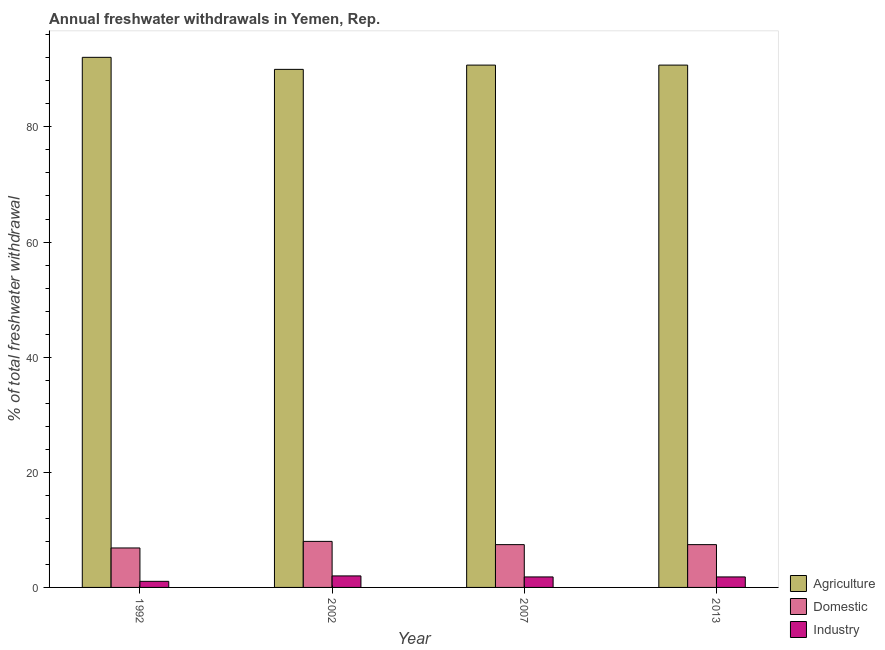How many groups of bars are there?
Ensure brevity in your answer.  4. How many bars are there on the 2nd tick from the left?
Offer a terse response. 3. How many bars are there on the 4th tick from the right?
Your answer should be very brief. 3. In how many cases, is the number of bars for a given year not equal to the number of legend labels?
Your answer should be compact. 0. What is the percentage of freshwater withdrawal for domestic purposes in 2007?
Provide a succinct answer. 7.43. Across all years, what is the maximum percentage of freshwater withdrawal for industry?
Offer a very short reply. 2. Across all years, what is the minimum percentage of freshwater withdrawal for domestic purposes?
Give a very brief answer. 6.86. In which year was the percentage of freshwater withdrawal for domestic purposes maximum?
Provide a succinct answer. 2002. What is the total percentage of freshwater withdrawal for agriculture in the graph?
Provide a succinct answer. 363.57. What is the difference between the percentage of freshwater withdrawal for domestic purposes in 2002 and that in 2007?
Your answer should be very brief. 0.57. What is the average percentage of freshwater withdrawal for industry per year?
Offer a very short reply. 1.68. In the year 2002, what is the difference between the percentage of freshwater withdrawal for domestic purposes and percentage of freshwater withdrawal for agriculture?
Make the answer very short. 0. What is the ratio of the percentage of freshwater withdrawal for agriculture in 2002 to that in 2007?
Offer a very short reply. 0.99. Is the percentage of freshwater withdrawal for agriculture in 2002 less than that in 2013?
Give a very brief answer. Yes. What is the difference between the highest and the second highest percentage of freshwater withdrawal for industry?
Keep it short and to the point. 0.18. What is the difference between the highest and the lowest percentage of freshwater withdrawal for industry?
Your answer should be very brief. 0.94. In how many years, is the percentage of freshwater withdrawal for industry greater than the average percentage of freshwater withdrawal for industry taken over all years?
Provide a short and direct response. 3. What does the 2nd bar from the left in 2002 represents?
Give a very brief answer. Domestic. What does the 2nd bar from the right in 2007 represents?
Your response must be concise. Domestic. What is the difference between two consecutive major ticks on the Y-axis?
Provide a short and direct response. 20. Does the graph contain grids?
Provide a succinct answer. No. Where does the legend appear in the graph?
Your answer should be compact. Bottom right. What is the title of the graph?
Your answer should be compact. Annual freshwater withdrawals in Yemen, Rep. What is the label or title of the Y-axis?
Your response must be concise. % of total freshwater withdrawal. What is the % of total freshwater withdrawal in Agriculture in 1992?
Provide a succinct answer. 92.09. What is the % of total freshwater withdrawal in Domestic in 1992?
Offer a very short reply. 6.86. What is the % of total freshwater withdrawal of Industry in 1992?
Provide a succinct answer. 1.06. What is the % of total freshwater withdrawal of Domestic in 2002?
Offer a very short reply. 8. What is the % of total freshwater withdrawal of Industry in 2002?
Your response must be concise. 2. What is the % of total freshwater withdrawal of Agriculture in 2007?
Your answer should be compact. 90.74. What is the % of total freshwater withdrawal of Domestic in 2007?
Provide a short and direct response. 7.43. What is the % of total freshwater withdrawal of Industry in 2007?
Your response must be concise. 1.82. What is the % of total freshwater withdrawal in Agriculture in 2013?
Keep it short and to the point. 90.74. What is the % of total freshwater withdrawal in Domestic in 2013?
Your response must be concise. 7.43. What is the % of total freshwater withdrawal in Industry in 2013?
Provide a short and direct response. 1.82. Across all years, what is the maximum % of total freshwater withdrawal of Agriculture?
Make the answer very short. 92.09. Across all years, what is the maximum % of total freshwater withdrawal of Domestic?
Make the answer very short. 8. Across all years, what is the minimum % of total freshwater withdrawal of Domestic?
Make the answer very short. 6.86. Across all years, what is the minimum % of total freshwater withdrawal in Industry?
Your answer should be very brief. 1.06. What is the total % of total freshwater withdrawal of Agriculture in the graph?
Keep it short and to the point. 363.57. What is the total % of total freshwater withdrawal of Domestic in the graph?
Offer a very short reply. 29.72. What is the total % of total freshwater withdrawal in Industry in the graph?
Keep it short and to the point. 6.7. What is the difference between the % of total freshwater withdrawal in Agriculture in 1992 and that in 2002?
Make the answer very short. 2.09. What is the difference between the % of total freshwater withdrawal of Domestic in 1992 and that in 2002?
Provide a succinct answer. -1.15. What is the difference between the % of total freshwater withdrawal in Industry in 1992 and that in 2002?
Provide a short and direct response. -0.94. What is the difference between the % of total freshwater withdrawal in Agriculture in 1992 and that in 2007?
Keep it short and to the point. 1.35. What is the difference between the % of total freshwater withdrawal in Domestic in 1992 and that in 2007?
Provide a succinct answer. -0.58. What is the difference between the % of total freshwater withdrawal of Industry in 1992 and that in 2007?
Offer a terse response. -0.77. What is the difference between the % of total freshwater withdrawal in Agriculture in 1992 and that in 2013?
Ensure brevity in your answer.  1.35. What is the difference between the % of total freshwater withdrawal in Domestic in 1992 and that in 2013?
Offer a terse response. -0.58. What is the difference between the % of total freshwater withdrawal in Industry in 1992 and that in 2013?
Make the answer very short. -0.77. What is the difference between the % of total freshwater withdrawal in Agriculture in 2002 and that in 2007?
Your answer should be very brief. -0.74. What is the difference between the % of total freshwater withdrawal in Domestic in 2002 and that in 2007?
Your response must be concise. 0.57. What is the difference between the % of total freshwater withdrawal in Industry in 2002 and that in 2007?
Offer a terse response. 0.18. What is the difference between the % of total freshwater withdrawal of Agriculture in 2002 and that in 2013?
Give a very brief answer. -0.74. What is the difference between the % of total freshwater withdrawal of Domestic in 2002 and that in 2013?
Provide a short and direct response. 0.57. What is the difference between the % of total freshwater withdrawal of Industry in 2002 and that in 2013?
Ensure brevity in your answer.  0.18. What is the difference between the % of total freshwater withdrawal in Domestic in 2007 and that in 2013?
Offer a very short reply. 0. What is the difference between the % of total freshwater withdrawal in Agriculture in 1992 and the % of total freshwater withdrawal in Domestic in 2002?
Offer a terse response. 84.09. What is the difference between the % of total freshwater withdrawal in Agriculture in 1992 and the % of total freshwater withdrawal in Industry in 2002?
Ensure brevity in your answer.  90.09. What is the difference between the % of total freshwater withdrawal in Domestic in 1992 and the % of total freshwater withdrawal in Industry in 2002?
Give a very brief answer. 4.86. What is the difference between the % of total freshwater withdrawal in Agriculture in 1992 and the % of total freshwater withdrawal in Domestic in 2007?
Your response must be concise. 84.66. What is the difference between the % of total freshwater withdrawal of Agriculture in 1992 and the % of total freshwater withdrawal of Industry in 2007?
Your response must be concise. 90.27. What is the difference between the % of total freshwater withdrawal of Domestic in 1992 and the % of total freshwater withdrawal of Industry in 2007?
Keep it short and to the point. 5.03. What is the difference between the % of total freshwater withdrawal in Agriculture in 1992 and the % of total freshwater withdrawal in Domestic in 2013?
Make the answer very short. 84.66. What is the difference between the % of total freshwater withdrawal in Agriculture in 1992 and the % of total freshwater withdrawal in Industry in 2013?
Keep it short and to the point. 90.27. What is the difference between the % of total freshwater withdrawal of Domestic in 1992 and the % of total freshwater withdrawal of Industry in 2013?
Offer a very short reply. 5.03. What is the difference between the % of total freshwater withdrawal in Agriculture in 2002 and the % of total freshwater withdrawal in Domestic in 2007?
Make the answer very short. 82.57. What is the difference between the % of total freshwater withdrawal of Agriculture in 2002 and the % of total freshwater withdrawal of Industry in 2007?
Your answer should be compact. 88.18. What is the difference between the % of total freshwater withdrawal in Domestic in 2002 and the % of total freshwater withdrawal in Industry in 2007?
Your answer should be compact. 6.18. What is the difference between the % of total freshwater withdrawal in Agriculture in 2002 and the % of total freshwater withdrawal in Domestic in 2013?
Your answer should be very brief. 82.57. What is the difference between the % of total freshwater withdrawal in Agriculture in 2002 and the % of total freshwater withdrawal in Industry in 2013?
Your response must be concise. 88.18. What is the difference between the % of total freshwater withdrawal of Domestic in 2002 and the % of total freshwater withdrawal of Industry in 2013?
Your response must be concise. 6.18. What is the difference between the % of total freshwater withdrawal of Agriculture in 2007 and the % of total freshwater withdrawal of Domestic in 2013?
Your answer should be compact. 83.31. What is the difference between the % of total freshwater withdrawal in Agriculture in 2007 and the % of total freshwater withdrawal in Industry in 2013?
Your answer should be very brief. 88.92. What is the difference between the % of total freshwater withdrawal of Domestic in 2007 and the % of total freshwater withdrawal of Industry in 2013?
Give a very brief answer. 5.61. What is the average % of total freshwater withdrawal of Agriculture per year?
Make the answer very short. 90.89. What is the average % of total freshwater withdrawal in Domestic per year?
Make the answer very short. 7.43. What is the average % of total freshwater withdrawal in Industry per year?
Provide a short and direct response. 1.68. In the year 1992, what is the difference between the % of total freshwater withdrawal of Agriculture and % of total freshwater withdrawal of Domestic?
Give a very brief answer. 85.23. In the year 1992, what is the difference between the % of total freshwater withdrawal of Agriculture and % of total freshwater withdrawal of Industry?
Your answer should be very brief. 91.03. In the year 1992, what is the difference between the % of total freshwater withdrawal of Domestic and % of total freshwater withdrawal of Industry?
Give a very brief answer. 5.8. In the year 2002, what is the difference between the % of total freshwater withdrawal in Domestic and % of total freshwater withdrawal in Industry?
Make the answer very short. 6. In the year 2007, what is the difference between the % of total freshwater withdrawal of Agriculture and % of total freshwater withdrawal of Domestic?
Ensure brevity in your answer.  83.31. In the year 2007, what is the difference between the % of total freshwater withdrawal in Agriculture and % of total freshwater withdrawal in Industry?
Your answer should be very brief. 88.92. In the year 2007, what is the difference between the % of total freshwater withdrawal of Domestic and % of total freshwater withdrawal of Industry?
Provide a succinct answer. 5.61. In the year 2013, what is the difference between the % of total freshwater withdrawal of Agriculture and % of total freshwater withdrawal of Domestic?
Your answer should be compact. 83.31. In the year 2013, what is the difference between the % of total freshwater withdrawal of Agriculture and % of total freshwater withdrawal of Industry?
Ensure brevity in your answer.  88.92. In the year 2013, what is the difference between the % of total freshwater withdrawal of Domestic and % of total freshwater withdrawal of Industry?
Your answer should be very brief. 5.61. What is the ratio of the % of total freshwater withdrawal in Agriculture in 1992 to that in 2002?
Offer a very short reply. 1.02. What is the ratio of the % of total freshwater withdrawal in Domestic in 1992 to that in 2002?
Your answer should be very brief. 0.86. What is the ratio of the % of total freshwater withdrawal of Industry in 1992 to that in 2002?
Your answer should be very brief. 0.53. What is the ratio of the % of total freshwater withdrawal of Agriculture in 1992 to that in 2007?
Provide a succinct answer. 1.01. What is the ratio of the % of total freshwater withdrawal of Domestic in 1992 to that in 2007?
Give a very brief answer. 0.92. What is the ratio of the % of total freshwater withdrawal in Industry in 1992 to that in 2007?
Ensure brevity in your answer.  0.58. What is the ratio of the % of total freshwater withdrawal in Agriculture in 1992 to that in 2013?
Your answer should be very brief. 1.01. What is the ratio of the % of total freshwater withdrawal in Domestic in 1992 to that in 2013?
Offer a terse response. 0.92. What is the ratio of the % of total freshwater withdrawal in Industry in 1992 to that in 2013?
Give a very brief answer. 0.58. What is the ratio of the % of total freshwater withdrawal of Domestic in 2002 to that in 2007?
Offer a very short reply. 1.08. What is the ratio of the % of total freshwater withdrawal in Industry in 2002 to that in 2007?
Your response must be concise. 1.1. What is the ratio of the % of total freshwater withdrawal of Domestic in 2002 to that in 2013?
Provide a short and direct response. 1.08. What is the ratio of the % of total freshwater withdrawal in Industry in 2002 to that in 2013?
Make the answer very short. 1.1. What is the difference between the highest and the second highest % of total freshwater withdrawal in Agriculture?
Your answer should be compact. 1.35. What is the difference between the highest and the second highest % of total freshwater withdrawal in Domestic?
Your answer should be compact. 0.57. What is the difference between the highest and the second highest % of total freshwater withdrawal of Industry?
Offer a terse response. 0.18. What is the difference between the highest and the lowest % of total freshwater withdrawal in Agriculture?
Give a very brief answer. 2.09. What is the difference between the highest and the lowest % of total freshwater withdrawal of Domestic?
Make the answer very short. 1.15. What is the difference between the highest and the lowest % of total freshwater withdrawal in Industry?
Make the answer very short. 0.94. 